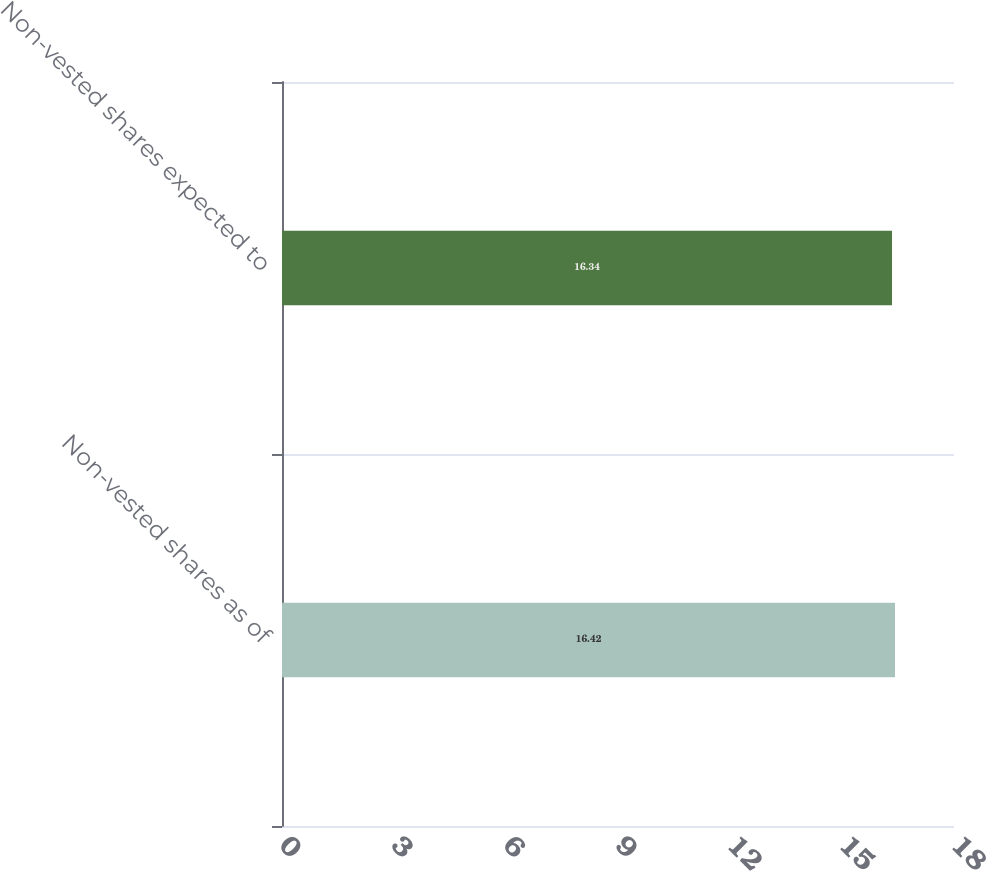<chart> <loc_0><loc_0><loc_500><loc_500><bar_chart><fcel>Non-vested shares as of<fcel>Non-vested shares expected to<nl><fcel>16.42<fcel>16.34<nl></chart> 